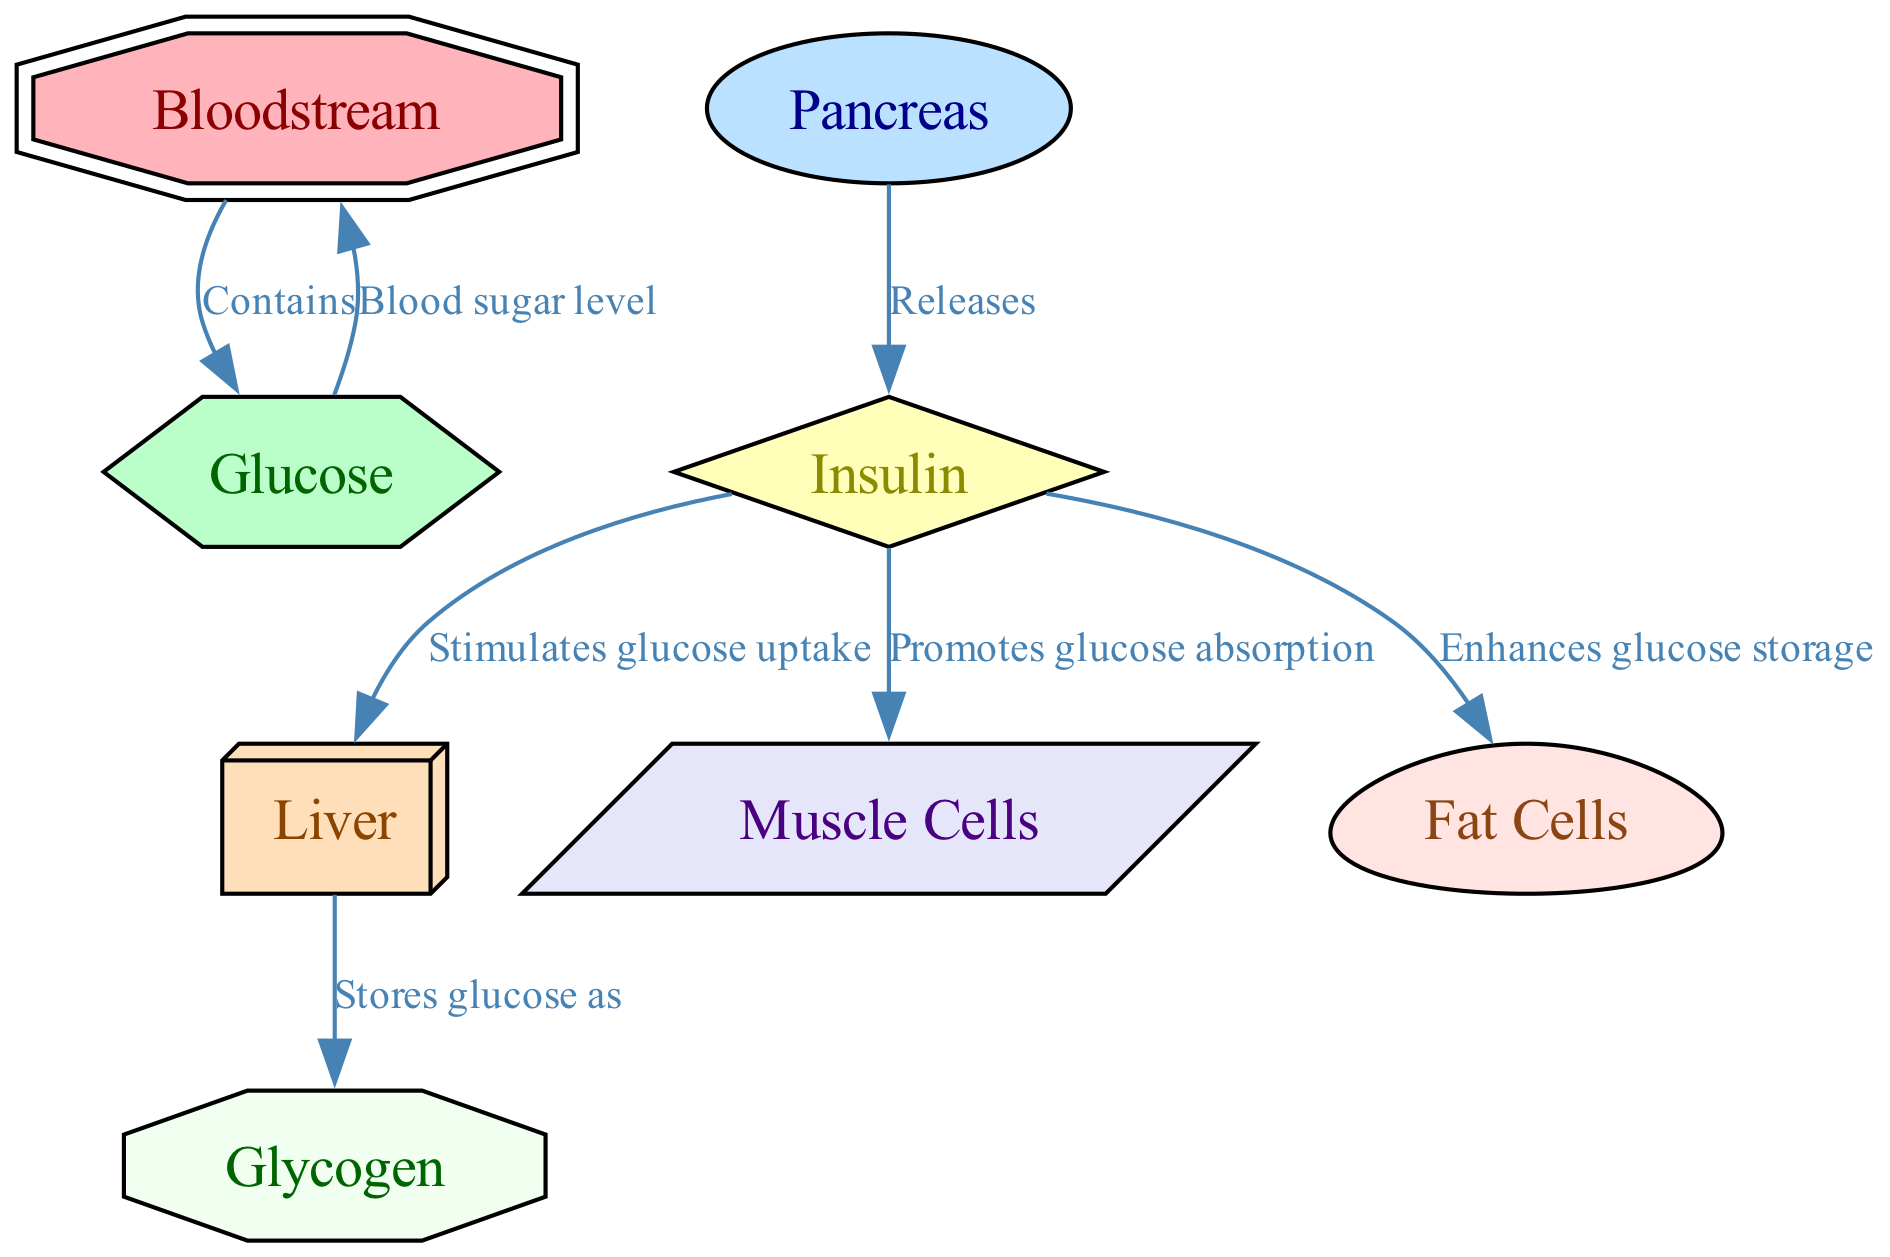What nodes are involved in glucose metabolism? The diagram lists several nodes related to glucose metabolism: Bloodstream, Glucose, Pancreas, Insulin, Liver, Muscle Cells, Fat Cells, and Glycogen.
Answer: Bloodstream, Glucose, Pancreas, Insulin, Liver, Muscle Cells, Fat Cells, Glycogen How many edges are there in the diagram? By counting the connections depicted in the diagram, there are a total of six edges linking the various nodes together, representing the relationships and flow of glucose metabolism.
Answer: Six What does the pancreas release? The diagram indicates that the pancreas releases Insulin, which plays a crucial role in glucose metabolism and regulating blood sugar levels.
Answer: Insulin Which cells promote glucose absorption? According to the diagram, Muscle Cells are specifically indicated to promote glucose absorption when stimulated by Insulin.
Answer: Muscle Cells What does insulin stimulate in the liver? The diagram portrays that Insulin stimulates glucose uptake in the liver, allowing the organ to manage glucose levels effectively.
Answer: Glucose uptake What is glucose stored as in the liver? The diagram indicates that glucose is stored as Glycogen in the liver, which is crucial for maintaining energy balance and blood sugar levels.
Answer: Glycogen What enhances glucose storage in fat cells? The diagram shows that Insulin enhances glucose storage in Fat Cells, contributing to overall energy storage and management in the body.
Answer: Glucose storage Which component indicates blood sugar level? The diagram connects Glucose to Bloodstream which signifies that Glucose directly indicates the blood sugar level.
Answer: Blood sugar level 